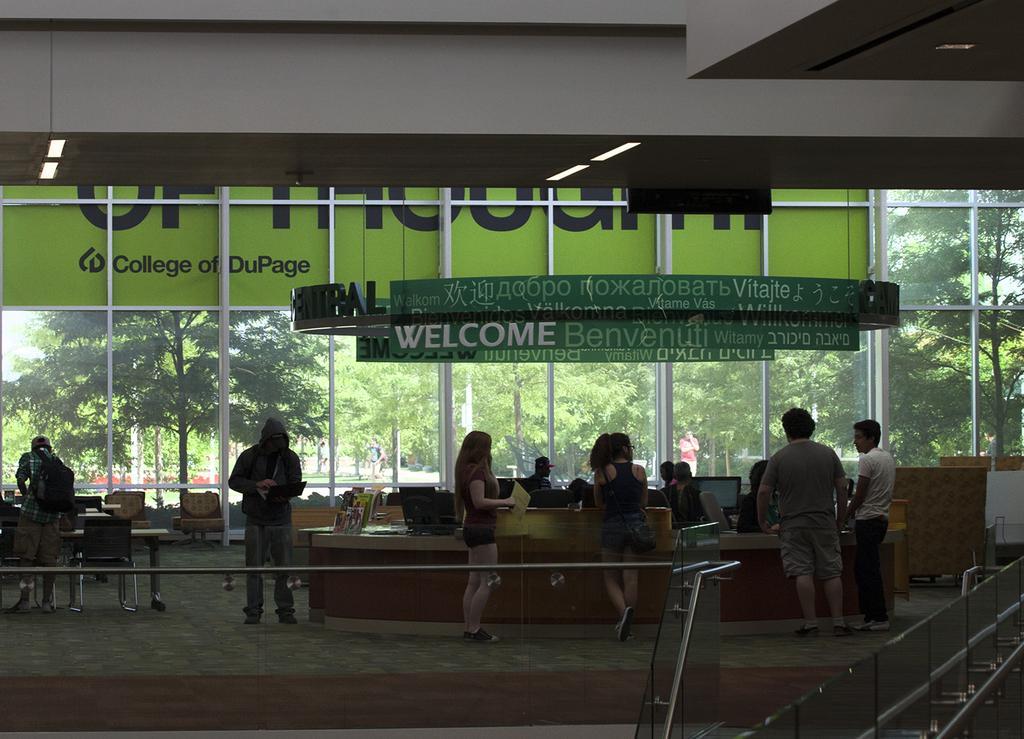Describe this image in one or two sentences. In this image I can see number of people. Also in the background I can see number of trees and board. 